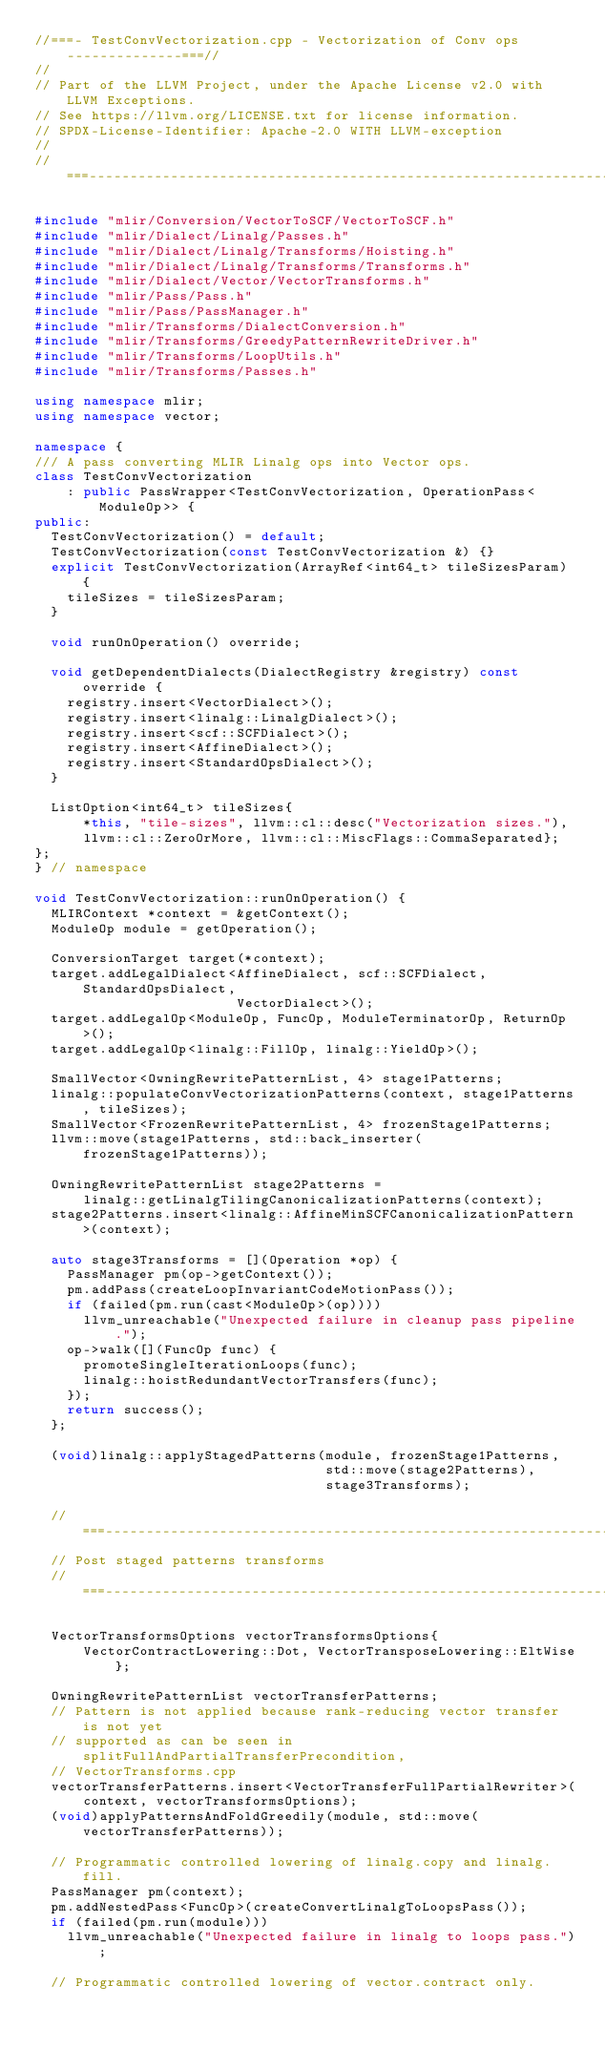<code> <loc_0><loc_0><loc_500><loc_500><_C++_>//===- TestConvVectorization.cpp - Vectorization of Conv ops --------------===//
//
// Part of the LLVM Project, under the Apache License v2.0 with LLVM Exceptions.
// See https://llvm.org/LICENSE.txt for license information.
// SPDX-License-Identifier: Apache-2.0 WITH LLVM-exception
//
//===----------------------------------------------------------------------===//

#include "mlir/Conversion/VectorToSCF/VectorToSCF.h"
#include "mlir/Dialect/Linalg/Passes.h"
#include "mlir/Dialect/Linalg/Transforms/Hoisting.h"
#include "mlir/Dialect/Linalg/Transforms/Transforms.h"
#include "mlir/Dialect/Vector/VectorTransforms.h"
#include "mlir/Pass/Pass.h"
#include "mlir/Pass/PassManager.h"
#include "mlir/Transforms/DialectConversion.h"
#include "mlir/Transforms/GreedyPatternRewriteDriver.h"
#include "mlir/Transforms/LoopUtils.h"
#include "mlir/Transforms/Passes.h"

using namespace mlir;
using namespace vector;

namespace {
/// A pass converting MLIR Linalg ops into Vector ops.
class TestConvVectorization
    : public PassWrapper<TestConvVectorization, OperationPass<ModuleOp>> {
public:
  TestConvVectorization() = default;
  TestConvVectorization(const TestConvVectorization &) {}
  explicit TestConvVectorization(ArrayRef<int64_t> tileSizesParam) {
    tileSizes = tileSizesParam;
  }

  void runOnOperation() override;

  void getDependentDialects(DialectRegistry &registry) const override {
    registry.insert<VectorDialect>();
    registry.insert<linalg::LinalgDialect>();
    registry.insert<scf::SCFDialect>();
    registry.insert<AffineDialect>();
    registry.insert<StandardOpsDialect>();
  }

  ListOption<int64_t> tileSizes{
      *this, "tile-sizes", llvm::cl::desc("Vectorization sizes."),
      llvm::cl::ZeroOrMore, llvm::cl::MiscFlags::CommaSeparated};
};
} // namespace

void TestConvVectorization::runOnOperation() {
  MLIRContext *context = &getContext();
  ModuleOp module = getOperation();

  ConversionTarget target(*context);
  target.addLegalDialect<AffineDialect, scf::SCFDialect, StandardOpsDialect,
                         VectorDialect>();
  target.addLegalOp<ModuleOp, FuncOp, ModuleTerminatorOp, ReturnOp>();
  target.addLegalOp<linalg::FillOp, linalg::YieldOp>();

  SmallVector<OwningRewritePatternList, 4> stage1Patterns;
  linalg::populateConvVectorizationPatterns(context, stage1Patterns, tileSizes);
  SmallVector<FrozenRewritePatternList, 4> frozenStage1Patterns;
  llvm::move(stage1Patterns, std::back_inserter(frozenStage1Patterns));

  OwningRewritePatternList stage2Patterns =
      linalg::getLinalgTilingCanonicalizationPatterns(context);
  stage2Patterns.insert<linalg::AffineMinSCFCanonicalizationPattern>(context);

  auto stage3Transforms = [](Operation *op) {
    PassManager pm(op->getContext());
    pm.addPass(createLoopInvariantCodeMotionPass());
    if (failed(pm.run(cast<ModuleOp>(op))))
      llvm_unreachable("Unexpected failure in cleanup pass pipeline.");
    op->walk([](FuncOp func) {
      promoteSingleIterationLoops(func);
      linalg::hoistRedundantVectorTransfers(func);
    });
    return success();
  };

  (void)linalg::applyStagedPatterns(module, frozenStage1Patterns,
                                    std::move(stage2Patterns),
                                    stage3Transforms);

  //===--------------------------------------------------------------------===//
  // Post staged patterns transforms
  //===--------------------------------------------------------------------===//

  VectorTransformsOptions vectorTransformsOptions{
      VectorContractLowering::Dot, VectorTransposeLowering::EltWise};

  OwningRewritePatternList vectorTransferPatterns;
  // Pattern is not applied because rank-reducing vector transfer is not yet
  // supported as can be seen in splitFullAndPartialTransferPrecondition,
  // VectorTransforms.cpp
  vectorTransferPatterns.insert<VectorTransferFullPartialRewriter>(
      context, vectorTransformsOptions);
  (void)applyPatternsAndFoldGreedily(module, std::move(vectorTransferPatterns));

  // Programmatic controlled lowering of linalg.copy and linalg.fill.
  PassManager pm(context);
  pm.addNestedPass<FuncOp>(createConvertLinalgToLoopsPass());
  if (failed(pm.run(module)))
    llvm_unreachable("Unexpected failure in linalg to loops pass.");

  // Programmatic controlled lowering of vector.contract only.</code> 